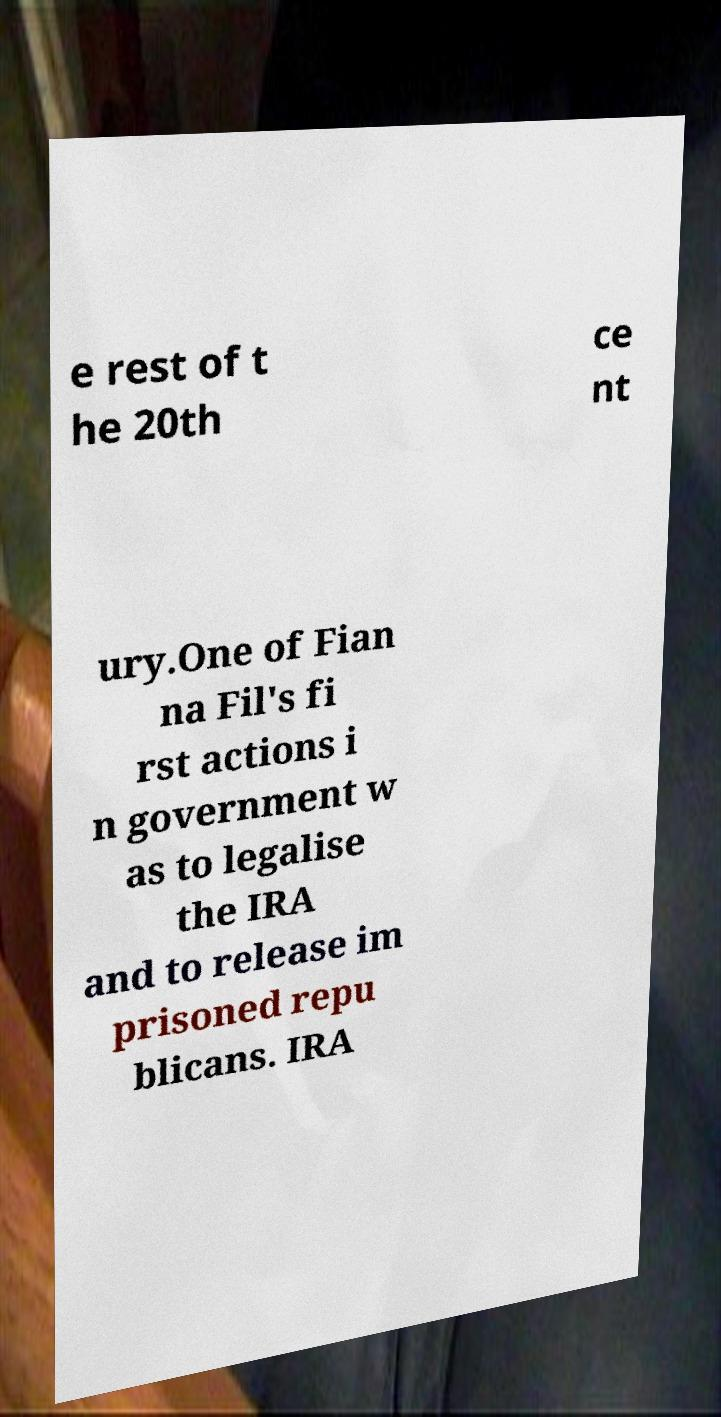I need the written content from this picture converted into text. Can you do that? e rest of t he 20th ce nt ury.One of Fian na Fil's fi rst actions i n government w as to legalise the IRA and to release im prisoned repu blicans. IRA 